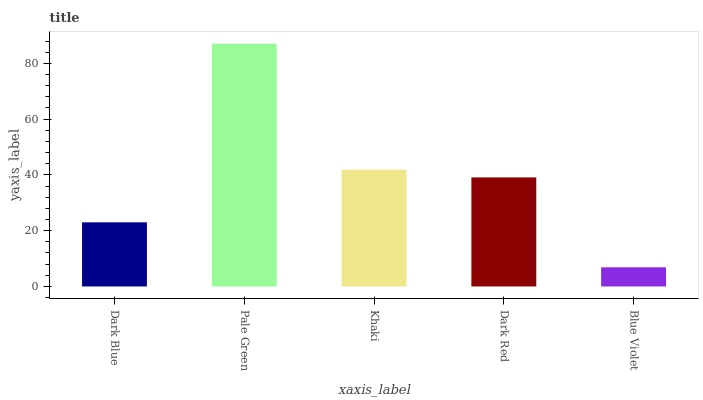Is Blue Violet the minimum?
Answer yes or no. Yes. Is Pale Green the maximum?
Answer yes or no. Yes. Is Khaki the minimum?
Answer yes or no. No. Is Khaki the maximum?
Answer yes or no. No. Is Pale Green greater than Khaki?
Answer yes or no. Yes. Is Khaki less than Pale Green?
Answer yes or no. Yes. Is Khaki greater than Pale Green?
Answer yes or no. No. Is Pale Green less than Khaki?
Answer yes or no. No. Is Dark Red the high median?
Answer yes or no. Yes. Is Dark Red the low median?
Answer yes or no. Yes. Is Blue Violet the high median?
Answer yes or no. No. Is Khaki the low median?
Answer yes or no. No. 